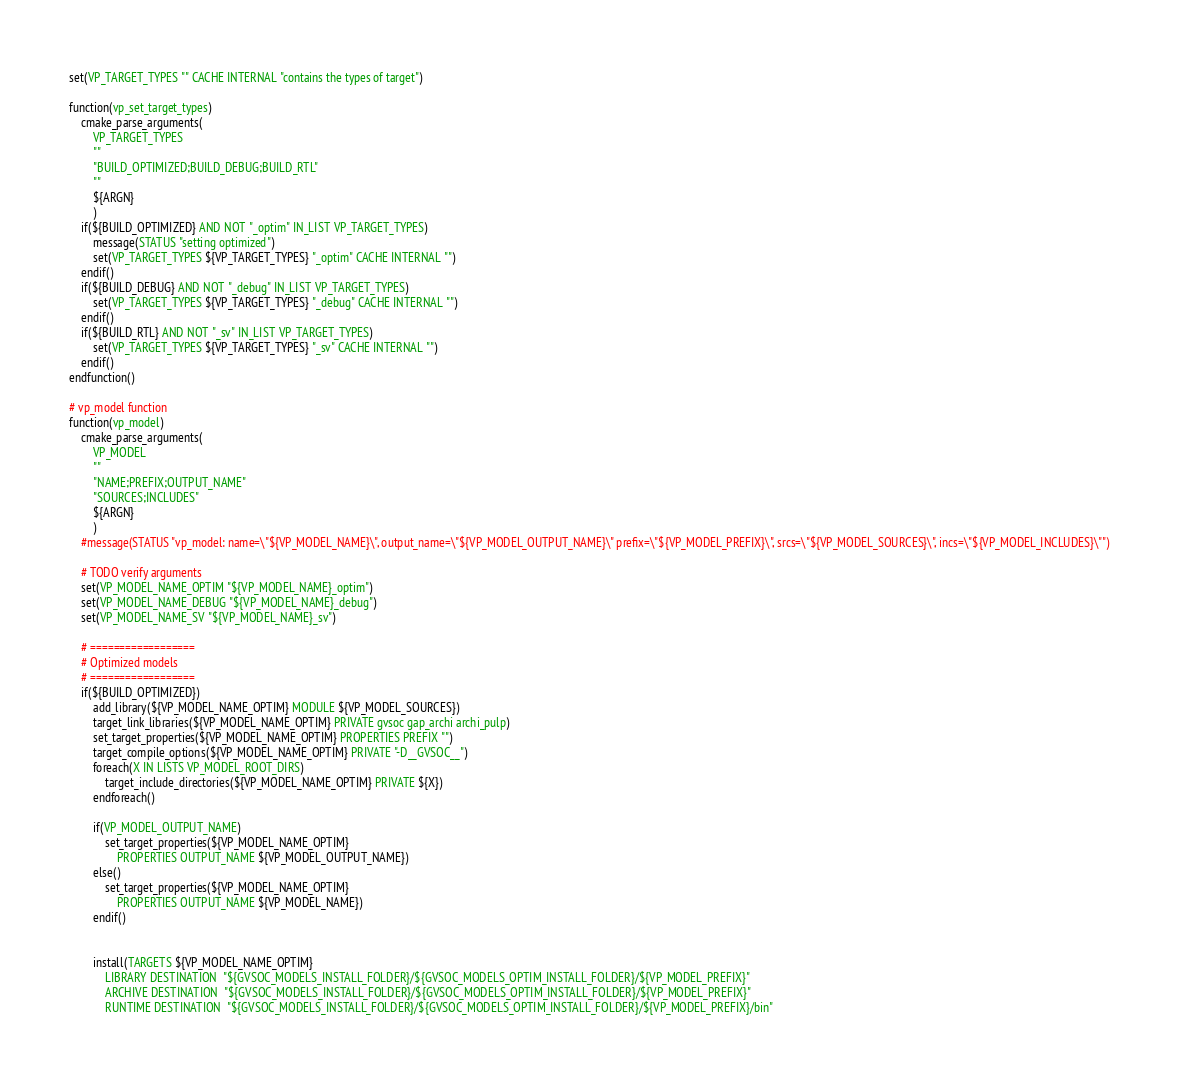<code> <loc_0><loc_0><loc_500><loc_500><_CMake_>set(VP_TARGET_TYPES "" CACHE INTERNAL "contains the types of target")

function(vp_set_target_types)
    cmake_parse_arguments(
        VP_TARGET_TYPES
        ""
        "BUILD_OPTIMIZED;BUILD_DEBUG;BUILD_RTL"
        ""
        ${ARGN}
        )
    if(${BUILD_OPTIMIZED} AND NOT "_optim" IN_LIST VP_TARGET_TYPES)
        message(STATUS "setting optimized")
        set(VP_TARGET_TYPES ${VP_TARGET_TYPES} "_optim" CACHE INTERNAL "")
    endif()
    if(${BUILD_DEBUG} AND NOT "_debug" IN_LIST VP_TARGET_TYPES)
        set(VP_TARGET_TYPES ${VP_TARGET_TYPES} "_debug" CACHE INTERNAL "")
    endif()
    if(${BUILD_RTL} AND NOT "_sv" IN_LIST VP_TARGET_TYPES)
        set(VP_TARGET_TYPES ${VP_TARGET_TYPES} "_sv" CACHE INTERNAL "")
    endif()
endfunction()

# vp_model function
function(vp_model)
    cmake_parse_arguments(
        VP_MODEL
        ""
        "NAME;PREFIX;OUTPUT_NAME"
        "SOURCES;INCLUDES"
        ${ARGN}
        )
    #message(STATUS "vp_model: name=\"${VP_MODEL_NAME}\", output_name=\"${VP_MODEL_OUTPUT_NAME}\" prefix=\"${VP_MODEL_PREFIX}\", srcs=\"${VP_MODEL_SOURCES}\", incs=\"${VP_MODEL_INCLUDES}\"")

    # TODO verify arguments
    set(VP_MODEL_NAME_OPTIM "${VP_MODEL_NAME}_optim")
    set(VP_MODEL_NAME_DEBUG "${VP_MODEL_NAME}_debug")
    set(VP_MODEL_NAME_SV "${VP_MODEL_NAME}_sv")

    # ==================
    # Optimized models
    # ==================
    if(${BUILD_OPTIMIZED})
        add_library(${VP_MODEL_NAME_OPTIM} MODULE ${VP_MODEL_SOURCES})
        target_link_libraries(${VP_MODEL_NAME_OPTIM} PRIVATE gvsoc gap_archi archi_pulp)
        set_target_properties(${VP_MODEL_NAME_OPTIM} PROPERTIES PREFIX "")
        target_compile_options(${VP_MODEL_NAME_OPTIM} PRIVATE "-D__GVSOC__")
        foreach(X IN LISTS VP_MODEL_ROOT_DIRS)
            target_include_directories(${VP_MODEL_NAME_OPTIM} PRIVATE ${X})
        endforeach()

        if(VP_MODEL_OUTPUT_NAME)
            set_target_properties(${VP_MODEL_NAME_OPTIM}
                PROPERTIES OUTPUT_NAME ${VP_MODEL_OUTPUT_NAME})
        else()
            set_target_properties(${VP_MODEL_NAME_OPTIM}
                PROPERTIES OUTPUT_NAME ${VP_MODEL_NAME})
        endif()


        install(TARGETS ${VP_MODEL_NAME_OPTIM}
            LIBRARY DESTINATION  "${GVSOC_MODELS_INSTALL_FOLDER}/${GVSOC_MODELS_OPTIM_INSTALL_FOLDER}/${VP_MODEL_PREFIX}"
            ARCHIVE DESTINATION  "${GVSOC_MODELS_INSTALL_FOLDER}/${GVSOC_MODELS_OPTIM_INSTALL_FOLDER}/${VP_MODEL_PREFIX}"
            RUNTIME DESTINATION  "${GVSOC_MODELS_INSTALL_FOLDER}/${GVSOC_MODELS_OPTIM_INSTALL_FOLDER}/${VP_MODEL_PREFIX}/bin"</code> 